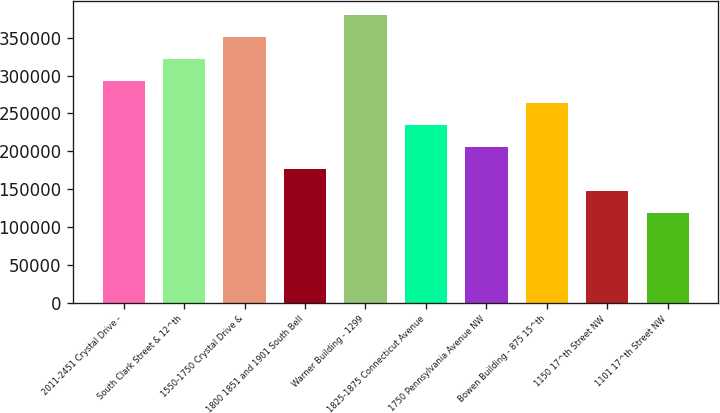Convert chart. <chart><loc_0><loc_0><loc_500><loc_500><bar_chart><fcel>2011-2451 Crystal Drive -<fcel>South Clark Street & 12^th<fcel>1550-1750 Crystal Drive &<fcel>1800 1851 and 1901 South Bell<fcel>Warner Building - 1299<fcel>1825-1875 Connecticut Avenue<fcel>1750 Pennsylvania Avenue NW<fcel>Bowen Building - 875 15^th<fcel>1150 17^th Street NW<fcel>1101 17^th Street NW<nl><fcel>292700<fcel>321867<fcel>351035<fcel>176031<fcel>380202<fcel>234365<fcel>205198<fcel>263533<fcel>146864<fcel>117696<nl></chart> 